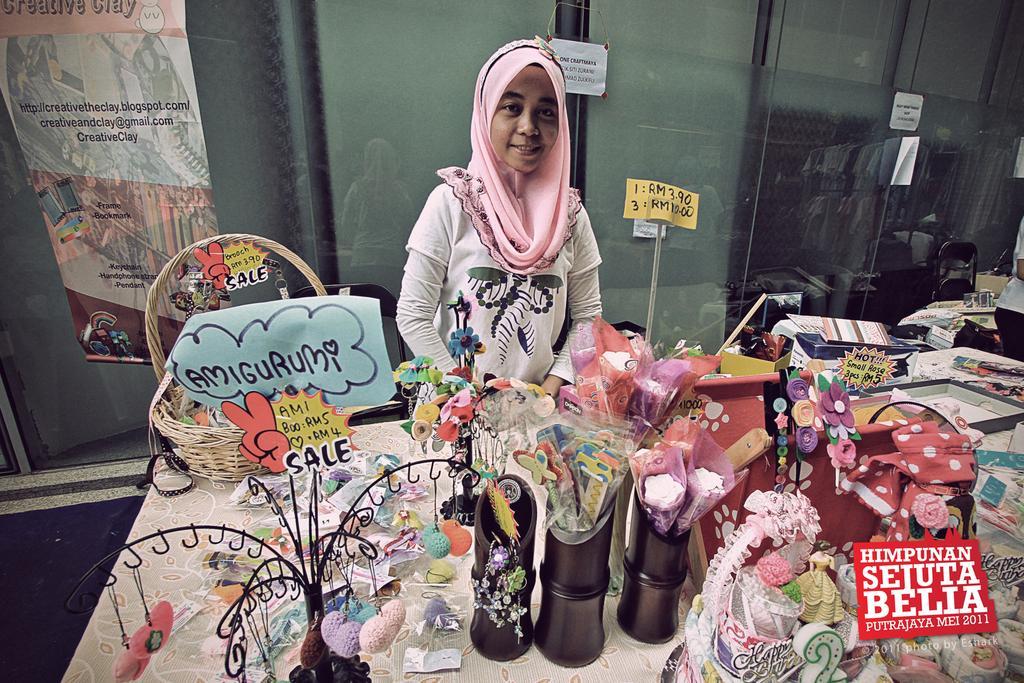Describe this image in one or two sentences. In this image we can see a person standing. In front of the person we can see a group of objects on a table. Behind the person we can see a glass. On the glass we can see a paper with text and we can see the reflection of objects and the person. On the left side, we can see a banner with text. In the bottom right we can see the text. 